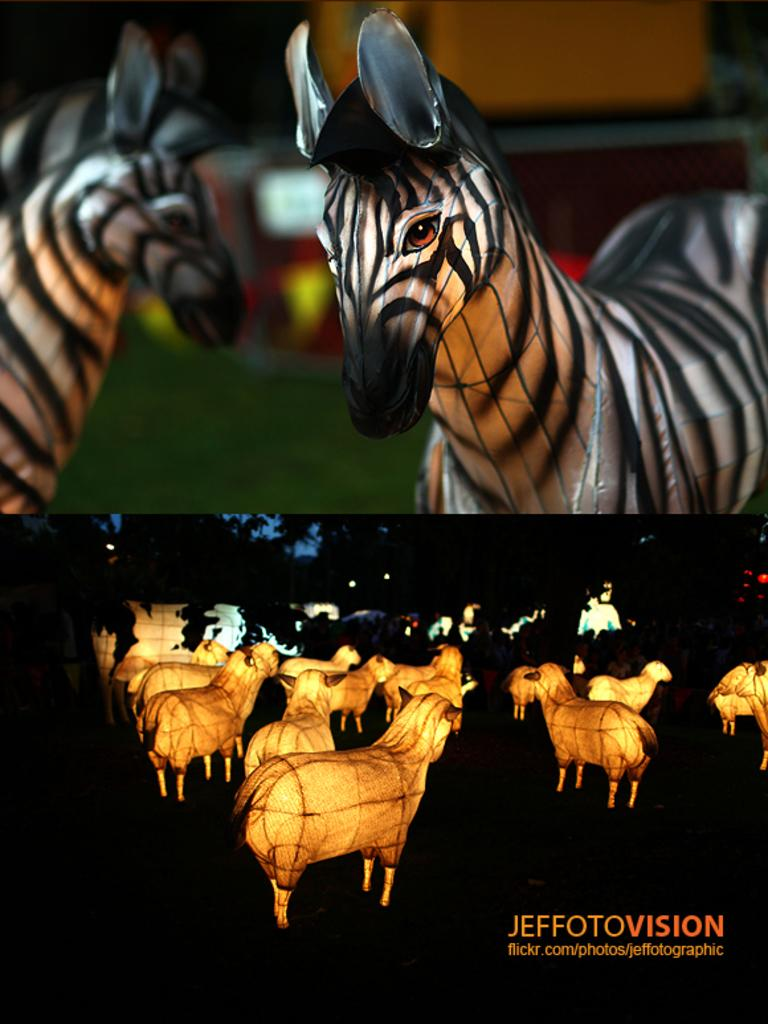What type of image is being described? The image is animated. What animals are present in the image? There are zebras in the image. Where is the text located in the image? The text is in the bottom right corner of the image. What historical event is being depicted by the zebras in the image? There is no specific historical event being depicted in the image; it simply features zebras. Can you see a man interacting with the zebras? There is no man present in the image. 